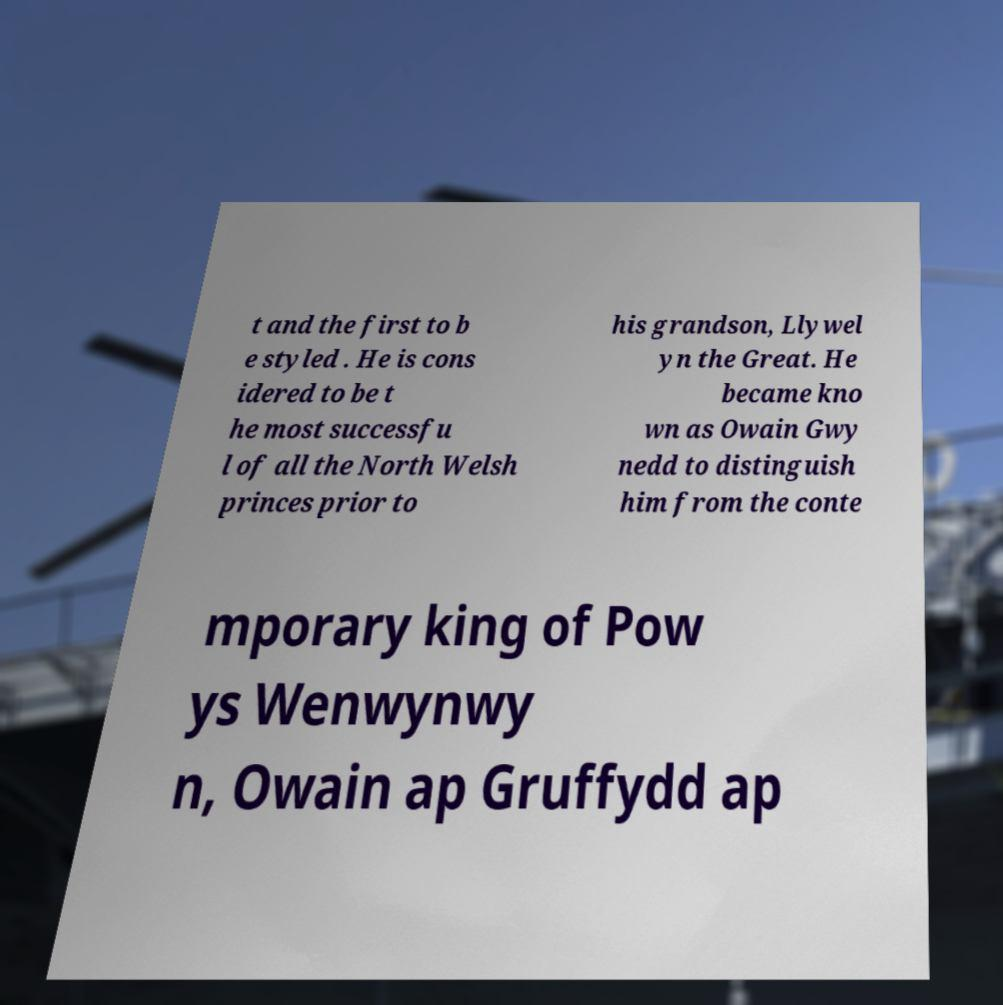Could you assist in decoding the text presented in this image and type it out clearly? t and the first to b e styled . He is cons idered to be t he most successfu l of all the North Welsh princes prior to his grandson, Llywel yn the Great. He became kno wn as Owain Gwy nedd to distinguish him from the conte mporary king of Pow ys Wenwynwy n, Owain ap Gruffydd ap 